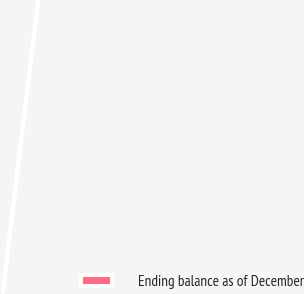Convert chart. <chart><loc_0><loc_0><loc_500><loc_500><pie_chart><fcel>Ending balance as of December<nl><fcel>100.0%<nl></chart> 